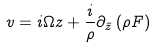Convert formula to latex. <formula><loc_0><loc_0><loc_500><loc_500>v = i \Omega z + \frac { i } { \rho } \partial _ { \bar { z } } \left ( \rho F \right )</formula> 